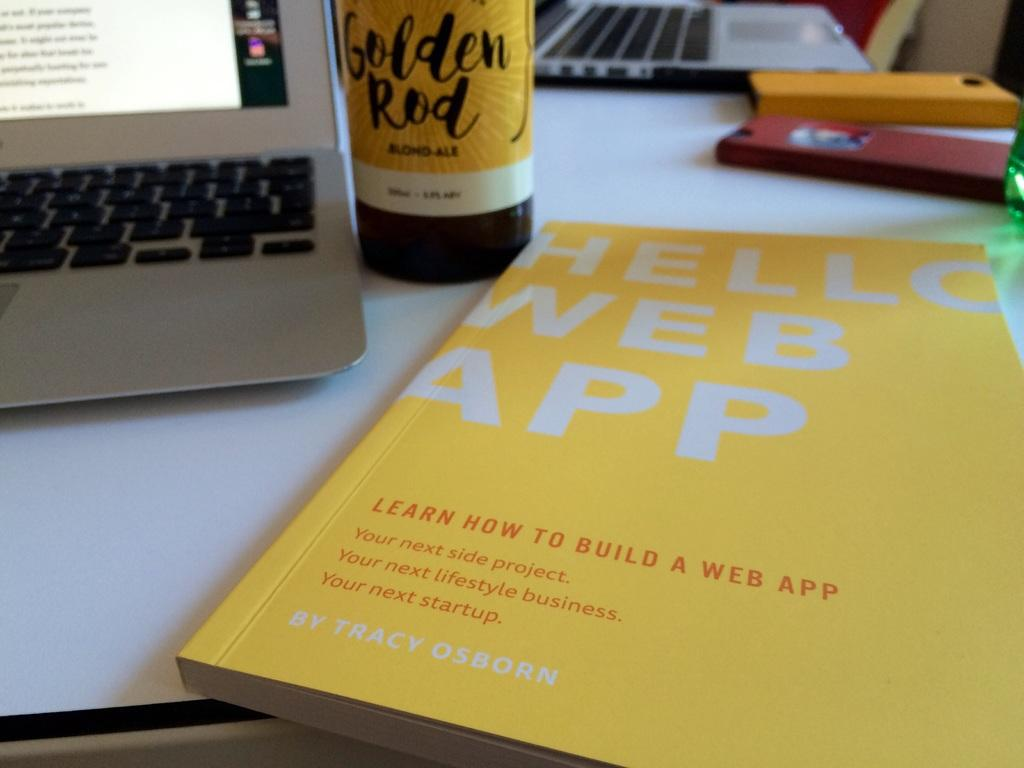Provide a one-sentence caption for the provided image. a book that has the words web app on it. 